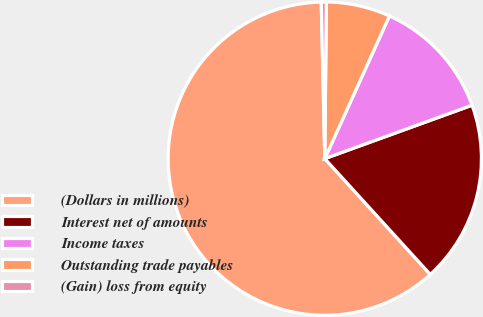Convert chart to OTSL. <chart><loc_0><loc_0><loc_500><loc_500><pie_chart><fcel>(Dollars in millions)<fcel>Interest net of amounts<fcel>Income taxes<fcel>Outstanding trade payables<fcel>(Gain) loss from equity<nl><fcel>61.4%<fcel>18.78%<fcel>12.69%<fcel>6.61%<fcel>0.52%<nl></chart> 